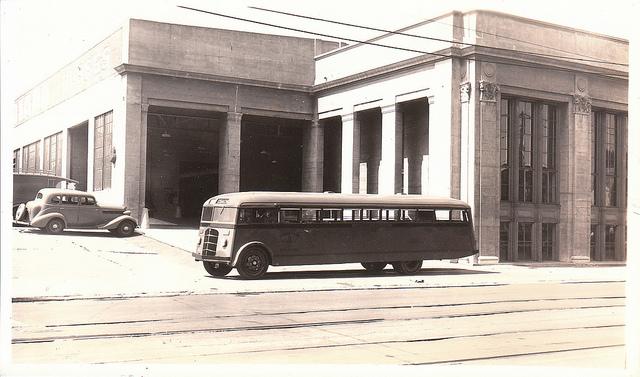How many vehicles are there?
Keep it brief. 2. Is this photo in color?
Keep it brief. No. Is this an old or recent picture?
Quick response, please. Old. 